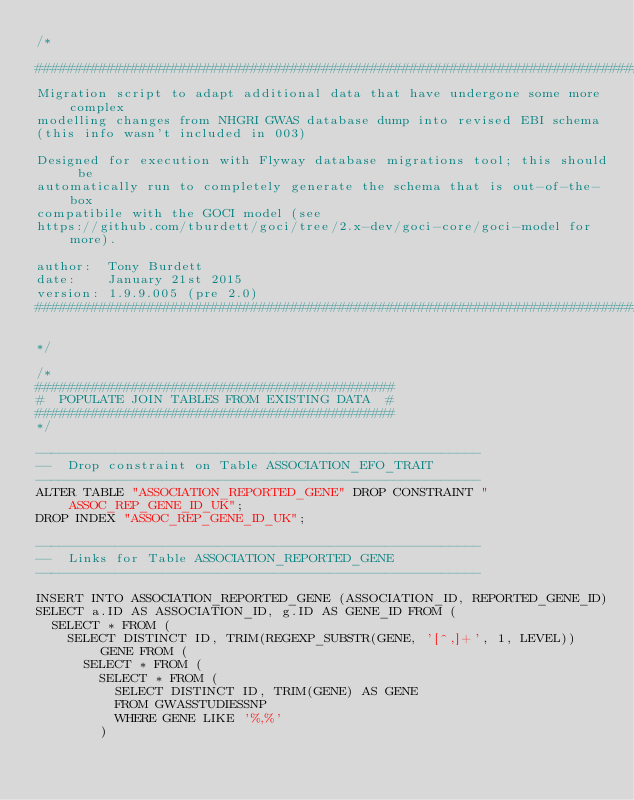Convert code to text. <code><loc_0><loc_0><loc_500><loc_500><_SQL_>/*

################################################################################
Migration script to adapt additional data that have undergone some more complex
modelling changes from NHGRI GWAS database dump into revised EBI schema
(this info wasn't included in 003)

Designed for execution with Flyway database migrations tool; this should be
automatically run to completely generate the schema that is out-of-the-box
compatibile with the GOCI model (see
https://github.com/tburdett/goci/tree/2.x-dev/goci-core/goci-model for more).

author:  Tony Burdett
date:    January 21st 2015
version: 1.9.9.005 (pre 2.0)
################################################################################

*/

/*
#############################################
#  POPULATE JOIN TABLES FROM EXISTING DATA  #
#############################################
*/

--------------------------------------------------------
--  Drop constraint on Table ASSOCIATION_EFO_TRAIT
--------------------------------------------------------
ALTER TABLE "ASSOCIATION_REPORTED_GENE" DROP CONSTRAINT "ASSOC_REP_GENE_ID_UK";
DROP INDEX "ASSOC_REP_GENE_ID_UK";

--------------------------------------------------------
--  Links for Table ASSOCIATION_REPORTED_GENE
--------------------------------------------------------

INSERT INTO ASSOCIATION_REPORTED_GENE (ASSOCIATION_ID, REPORTED_GENE_ID)
SELECT a.ID AS ASSOCIATION_ID, g.ID AS GENE_ID FROM (
  SELECT * FROM (
    SELECT DISTINCT ID, TRIM(REGEXP_SUBSTR(GENE, '[^,]+', 1, LEVEL)) GENE FROM (
      SELECT * FROM (
        SELECT * FROM (
          SELECT DISTINCT ID, TRIM(GENE) AS GENE
          FROM GWASSTUDIESSNP
          WHERE GENE LIKE '%,%'
        )</code> 